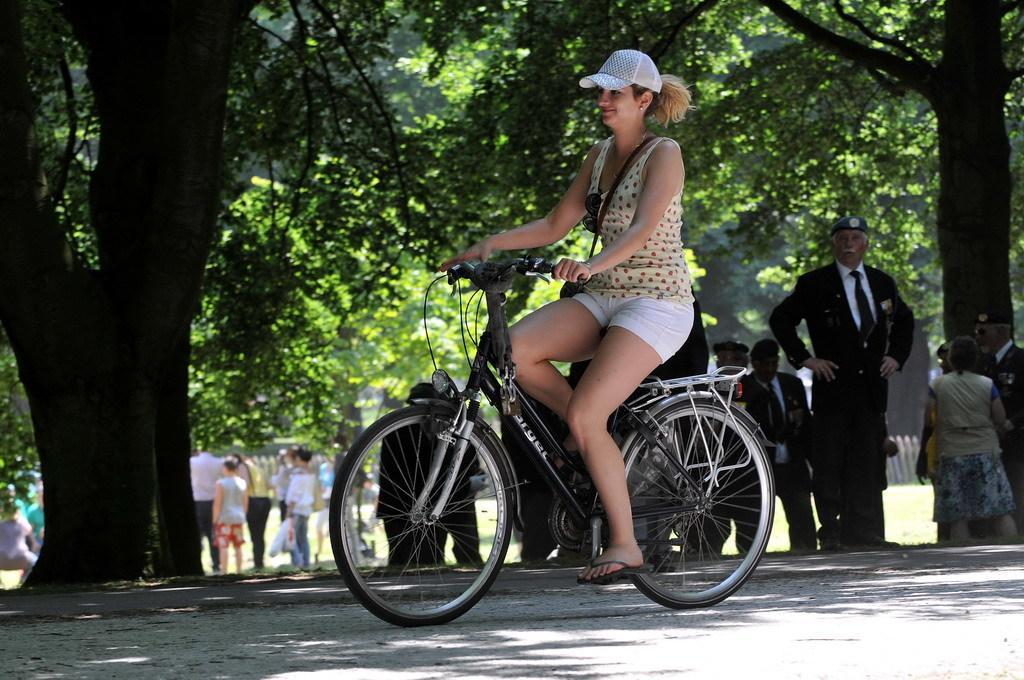Please provide a concise description of this image. This girl is riding his bicycle. She wore cap. This are trees. Far this persons are standing. Far there is a fence and grass. 